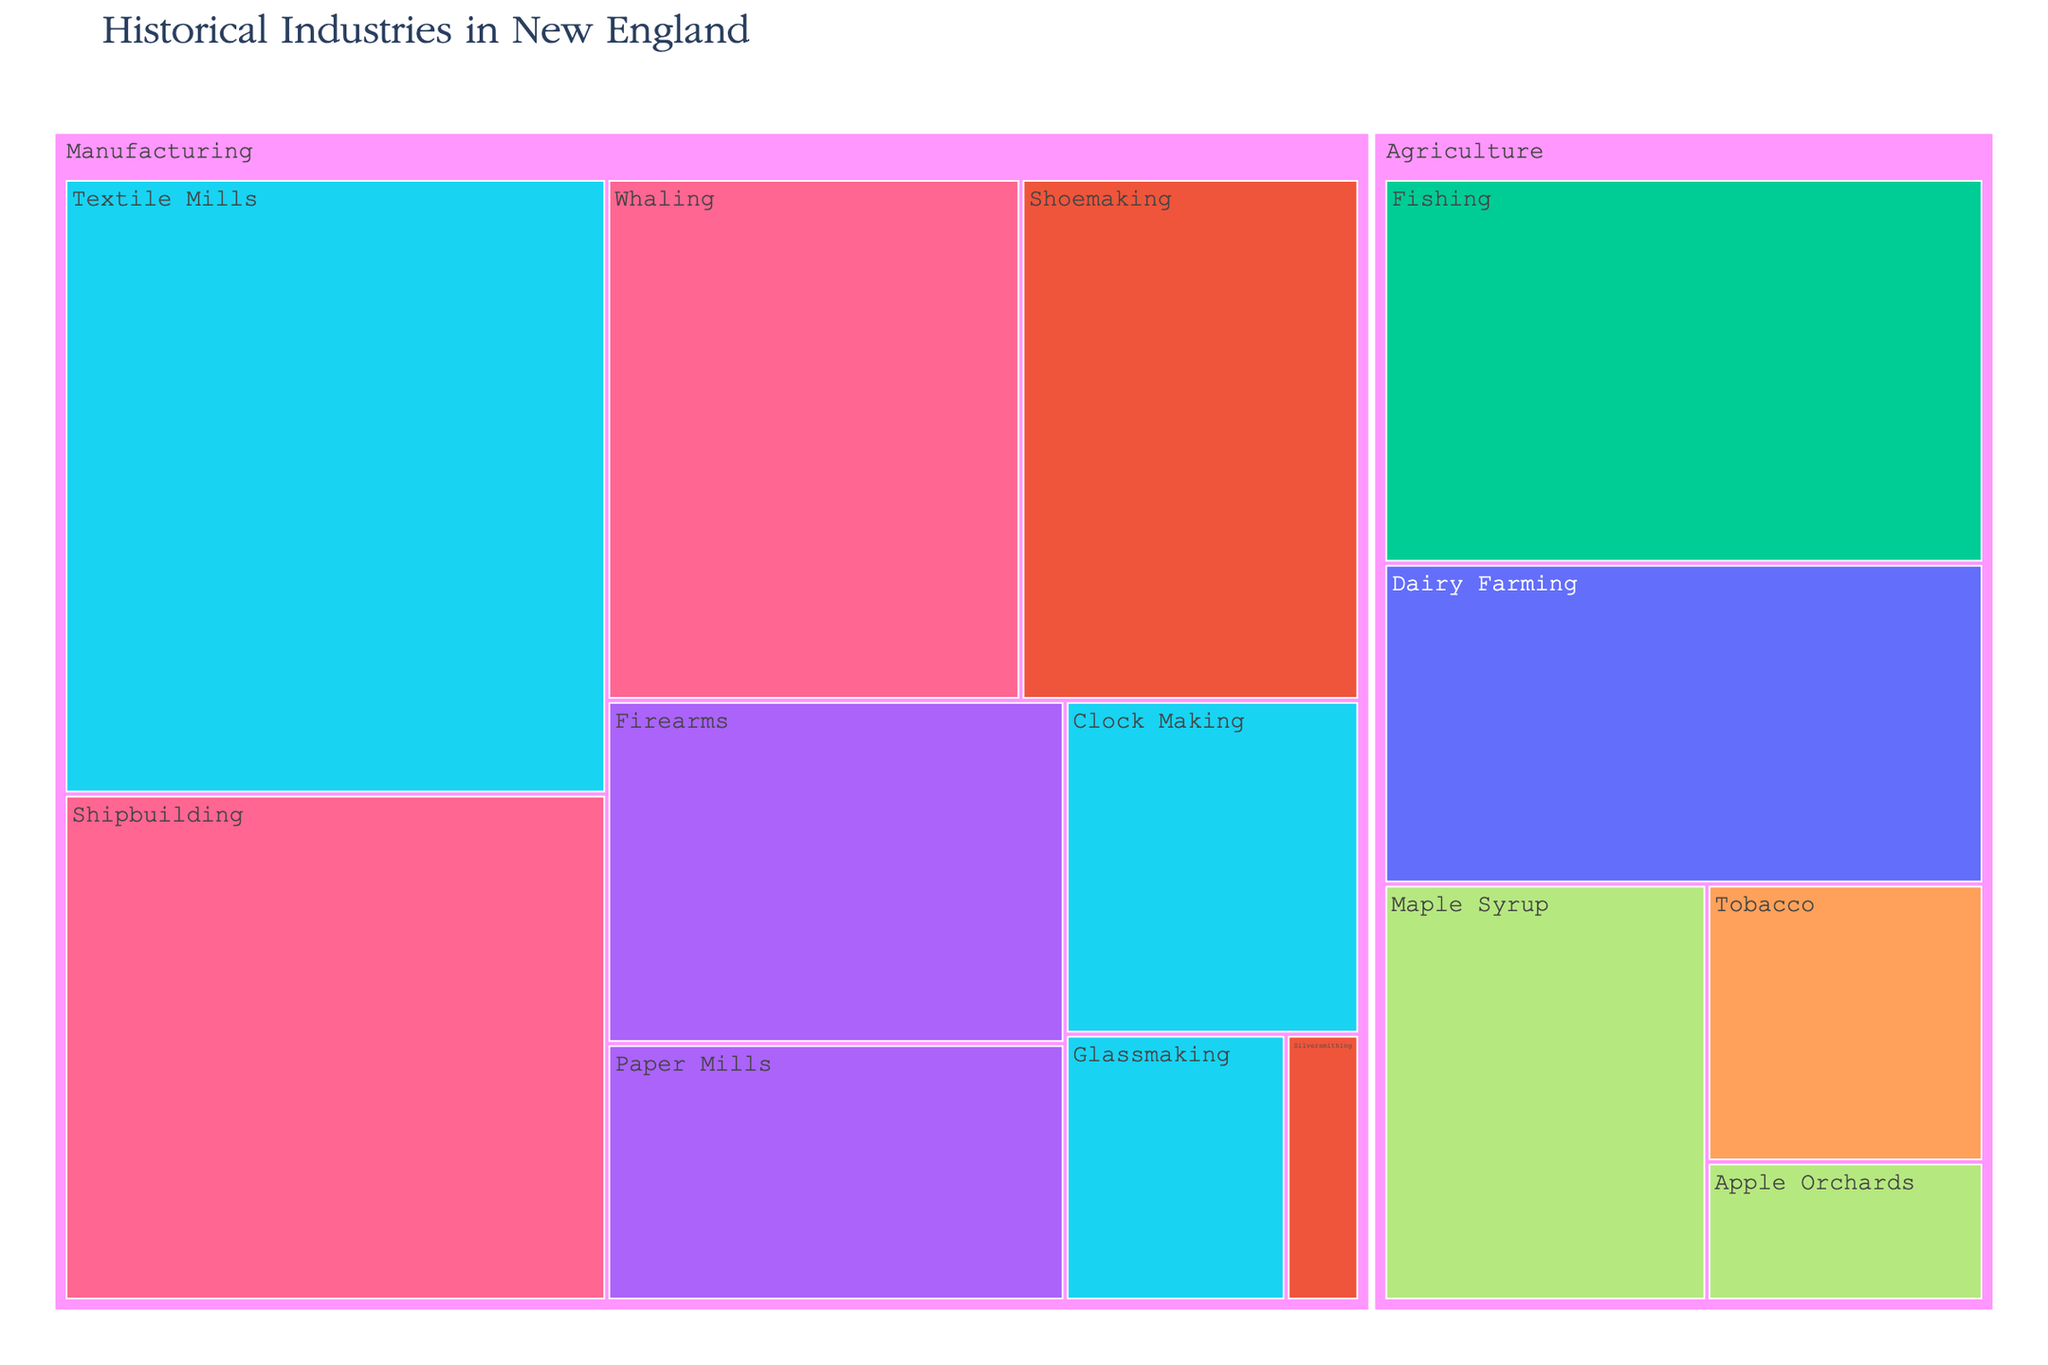What's the title of the treemap? The title of the treemap is usually found at the top of the figure, often in a larger or differently styled font. The title of this treemap is "Historical Industries in New England".
Answer: Historical Industries in New England Which industry within the Agricultural sector has the highest economic impact? To answer this, look for the largest segment within the Agriculture sector in the treemap. The largest segment represents Fishing with an economic impact of 60.
Answer: Fishing What is the combined economic impact of Shipbuilding and Whaling? Identify the economic impact values for Shipbuilding (70) and Whaling (55) and sum them up: 70 + 55.
Answer: 125 Which manufacturing industry spans the longest time period? Look for the Manufacturing industry with the widest time period mentioned. Shipbuilding and Whaling both span from 1750-1850, but Firearms spans from 1800-1950 which is the longest within Manufacturing.
Answer: Firearms Compare the economic impact of Textile Mills and Shoemaking. Which one contributed more? Identify the economic impact values for Textile Mills (85) and Shoemaking (45), and then compare them. Textile Mills has a greater economic impact.
Answer: Textile Mills What color represents economic activities from 1700-2000? Identify the color in the treemap legend that corresponds to the time period 1700-2000. The color coding helps to visually identify segments of specific time periods.
Answer: Color representing 1700-2000 (specific color would be seen on the figure) Which industry had the least economic impact in New England? Look for the smallest segment in the treemap, which represents Silversmithing with an economic impact of 5.
Answer: Silversmithing What's the economic impact difference between Dairy Farming and Apple Orchards? Identify the economic impact values for Dairy Farming (50) and Apple Orchards (10). Subtract the smaller value from the larger one: 50 - 10.
Answer: 40 How is the sector 'Agriculture' visually differentiated from 'Manufacturing' in the treemap? Sectors are often differentiated by distinct visual boundaries or color groupings. In a treemap, look for clear demarcations or parent boxes containing clusters of industries belonging to each sector.
Answer: Clear visual boundaries/different boxes Which three industries span the same time period from 1800-1900? Identify the industries and their associated time periods in the treemap: Textile Mills, Clock Making, and Glassmaking all span from 1800-1900.
Answer: Textile Mills, Clock Making, Glassmaking 